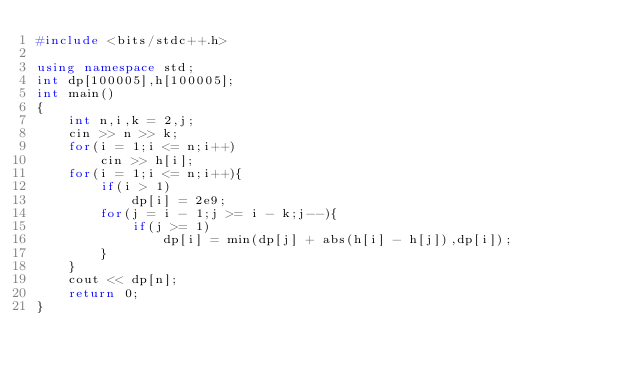Convert code to text. <code><loc_0><loc_0><loc_500><loc_500><_C++_>#include <bits/stdc++.h>

using namespace std;
int dp[100005],h[100005];
int main()
{
    int n,i,k = 2,j;
    cin >> n >> k;
    for(i = 1;i <= n;i++)
        cin >> h[i];
    for(i = 1;i <= n;i++){
        if(i > 1)
            dp[i] = 2e9;
        for(j = i - 1;j >= i - k;j--){
            if(j >= 1)
                dp[i] = min(dp[j] + abs(h[i] - h[j]),dp[i]);
        }
    }
    cout << dp[n];
    return 0;
}
</code> 